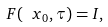<formula> <loc_0><loc_0><loc_500><loc_500>\ F ( \ x _ { 0 } , \tau ) = I ,</formula> 